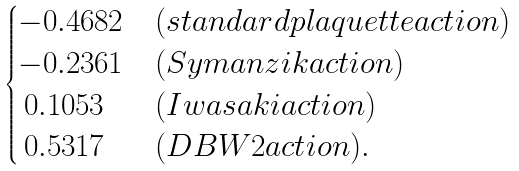<formula> <loc_0><loc_0><loc_500><loc_500>\begin{cases} - 0 . 4 6 8 2 & ( s t a n d a r d p l a q u e t t e a c t i o n ) \\ - 0 . 2 3 6 1 & ( S y m a n z i k a c t i o n ) \\ \, 0 . 1 0 5 3 & ( I w a s a k i a c t i o n ) \\ \, 0 . 5 3 1 7 & ( D B W 2 a c t i o n ) . \end{cases}</formula> 